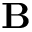<formula> <loc_0><loc_0><loc_500><loc_500>B</formula> 